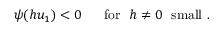Convert formula to latex. <formula><loc_0><loc_0><loc_500><loc_500>\psi ( h u _ { 1 } ) < 0 \quad \ f o r \ \ h \ne 0 \ \ s m a l l \ .</formula> 